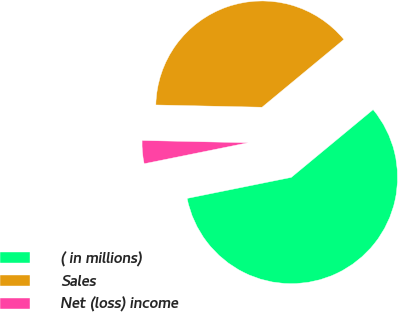Convert chart. <chart><loc_0><loc_0><loc_500><loc_500><pie_chart><fcel>( in millions)<fcel>Sales<fcel>Net (loss) income<nl><fcel>57.83%<fcel>38.65%<fcel>3.51%<nl></chart> 